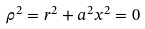<formula> <loc_0><loc_0><loc_500><loc_500>\rho ^ { 2 } = r ^ { 2 } + a ^ { 2 } x ^ { 2 } = 0</formula> 